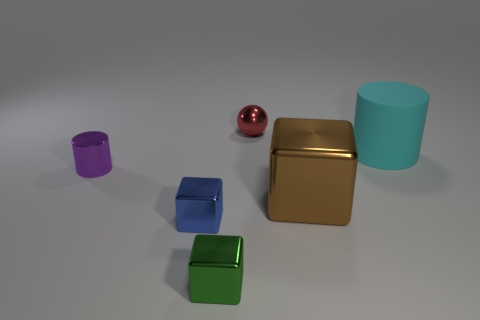Which objects in this image could be used to hold a small amount of liquid? The two cylindrical objects, one turquoise and one purple, could potentially hold a small amount of liquid due to their open-top design. 